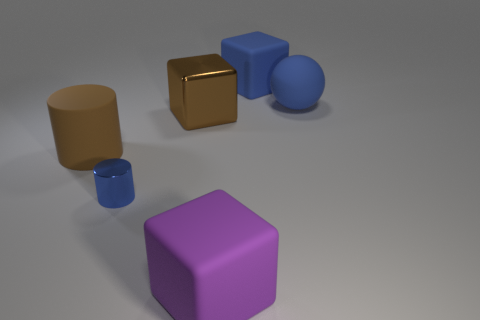Are there any reflections or shadows that give clues about the light source? Yes, there are subtle shadows cast to the right of the objects, suggesting that there is a light source coming from the left. The metallic cube has reflections that further indicate it is being illuminated from the left side of the scene. 